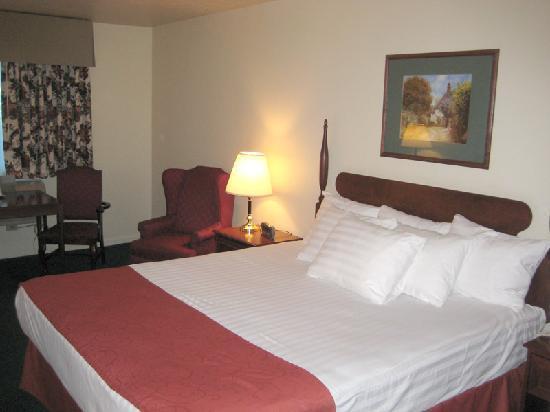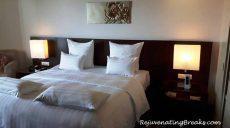The first image is the image on the left, the second image is the image on the right. For the images shown, is this caption "there are two beds in a room with a picture of a woman on the wall and a blue table between them" true? Answer yes or no. No. The first image is the image on the left, the second image is the image on the right. Analyze the images presented: Is the assertion "One room has twin beds with gray bedding, and the other room contains one larger bed with white pillows." valid? Answer yes or no. No. 